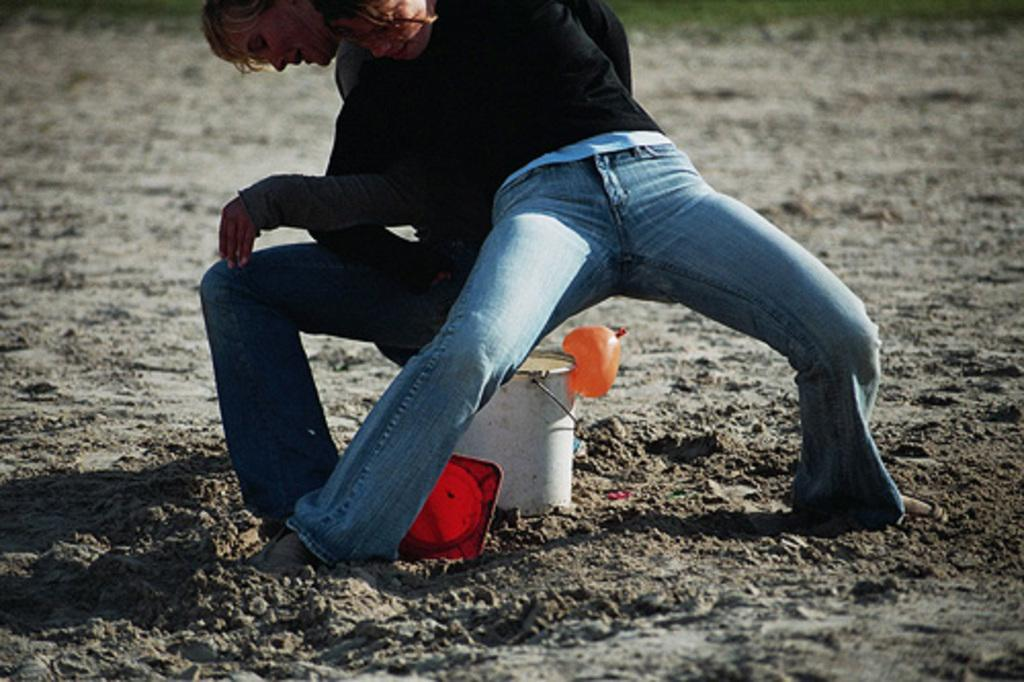How many people are in the image? There are two men in the image. What object can be seen in the image that is typically used for holding or carrying things? There is a bucket in the image. What color is the prominent object in the image? There is a red object in the image. What is being held by one of the men in the image? There is a balloon in the image. What type of terrain is visible in the image? There is sand visible in the image. Can you describe the background of the image? The background of the image is blurred. What type of vessel is being used to catch the current in the image? There is no vessel or current present in the image. What type of can is visible in the image? There is no can present in the image. 